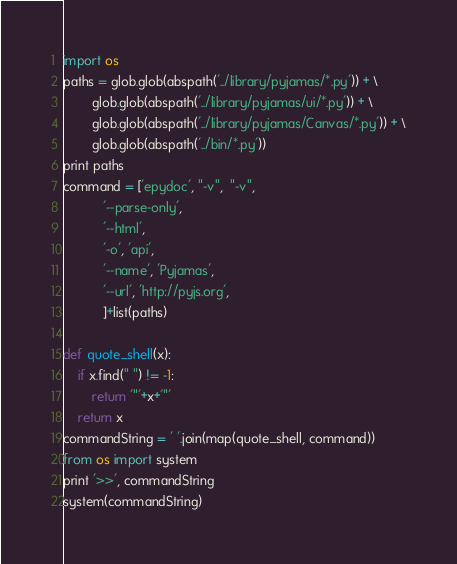<code> <loc_0><loc_0><loc_500><loc_500><_Python_>import os
paths = glob.glob(abspath('../library/pyjamas/*.py')) + \
        glob.glob(abspath('../library/pyjamas/ui/*.py')) + \
        glob.glob(abspath('../library/pyjamas/Canvas/*.py')) + \
        glob.glob(abspath('../bin/*.py'))
print paths
command = ['epydoc', "-v",  "-v",
           '--parse-only',
           '--html',
           '-o', 'api', 
           '--name', 'Pyjamas', 
           '--url', 'http://pyjs.org', 
           ]+list(paths)

def quote_shell(x):
    if x.find(" ") != -1:
        return '"'+x+'"'
    return x
commandString = ' '.join(map(quote_shell, command))
from os import system
print '>>', commandString
system(commandString)
</code> 